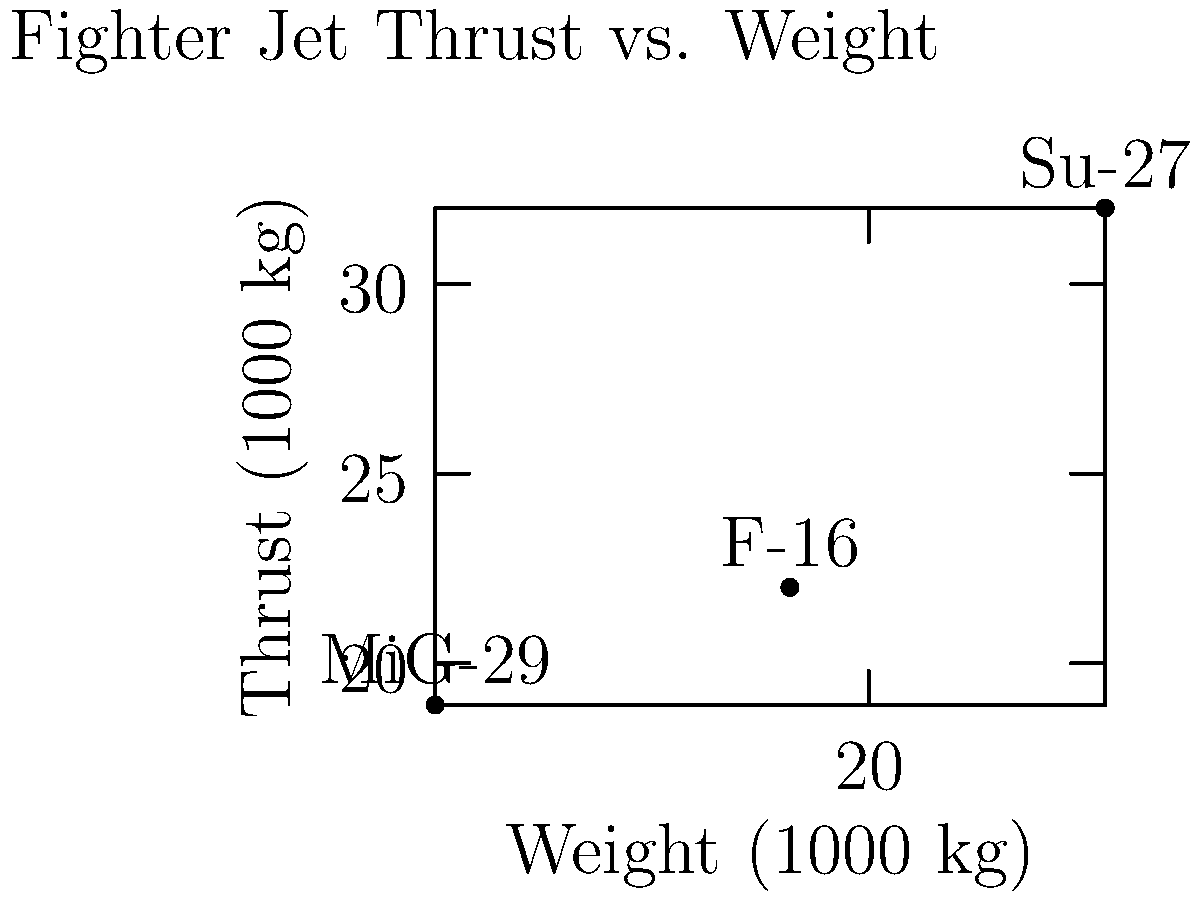Based on the graph showing the thrust and weight characteristics of three fighter jet models, which aircraft has the highest thrust-to-weight ratio? Calculate the ratios for all three models to support your answer. To solve this problem, we need to calculate the thrust-to-weight ratio for each fighter jet model and compare them. The thrust-to-weight ratio is calculated by dividing the thrust by the weight.

1. For the F-16:
   Thrust = 22,000 kg
   Weight = 19,000 kg
   Thrust-to-weight ratio = $\frac{22000}{19000} \approx 1.16$

2. For the MiG-29:
   Thrust = 18,900 kg
   Weight = 14,500 kg
   Thrust-to-weight ratio = $\frac{18900}{14500} \approx 1.30$

3. For the Su-27:
   Thrust = 32,000 kg
   Weight = 23,000 kg
   Thrust-to-weight ratio = $\frac{32000}{23000} \approx 1.39$

Comparing the ratios:
F-16: 1.16
MiG-29: 1.30
Su-27: 1.39

The Su-27 has the highest thrust-to-weight ratio among the three fighter jet models.
Answer: Su-27 with a thrust-to-weight ratio of 1.39 